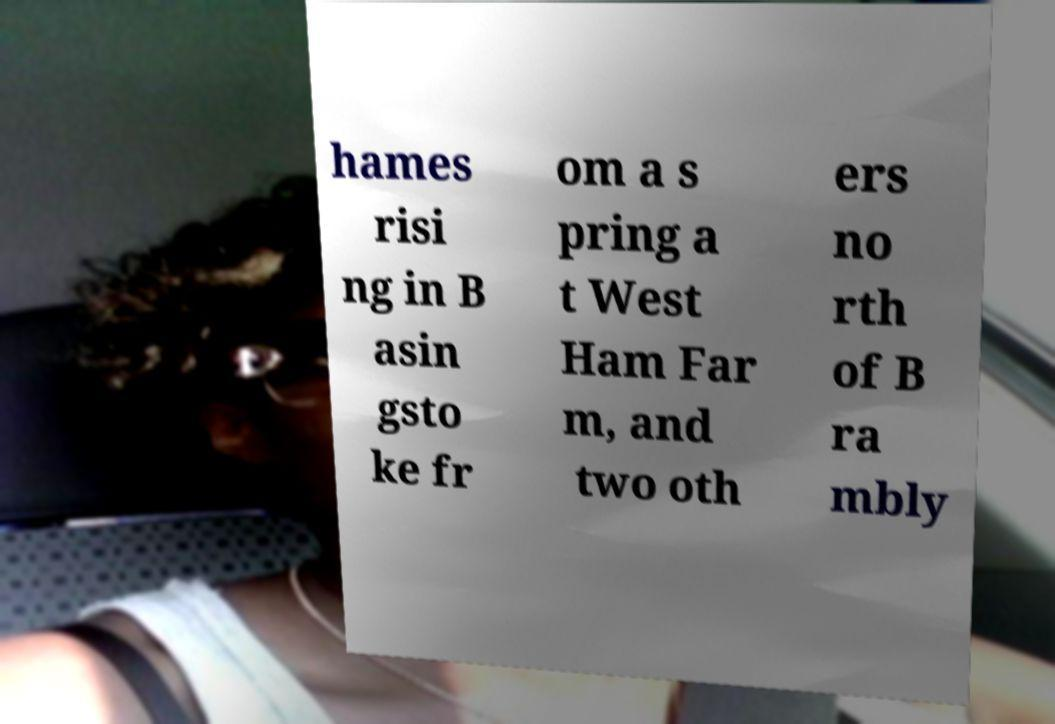Can you accurately transcribe the text from the provided image for me? hames risi ng in B asin gsto ke fr om a s pring a t West Ham Far m, and two oth ers no rth of B ra mbly 